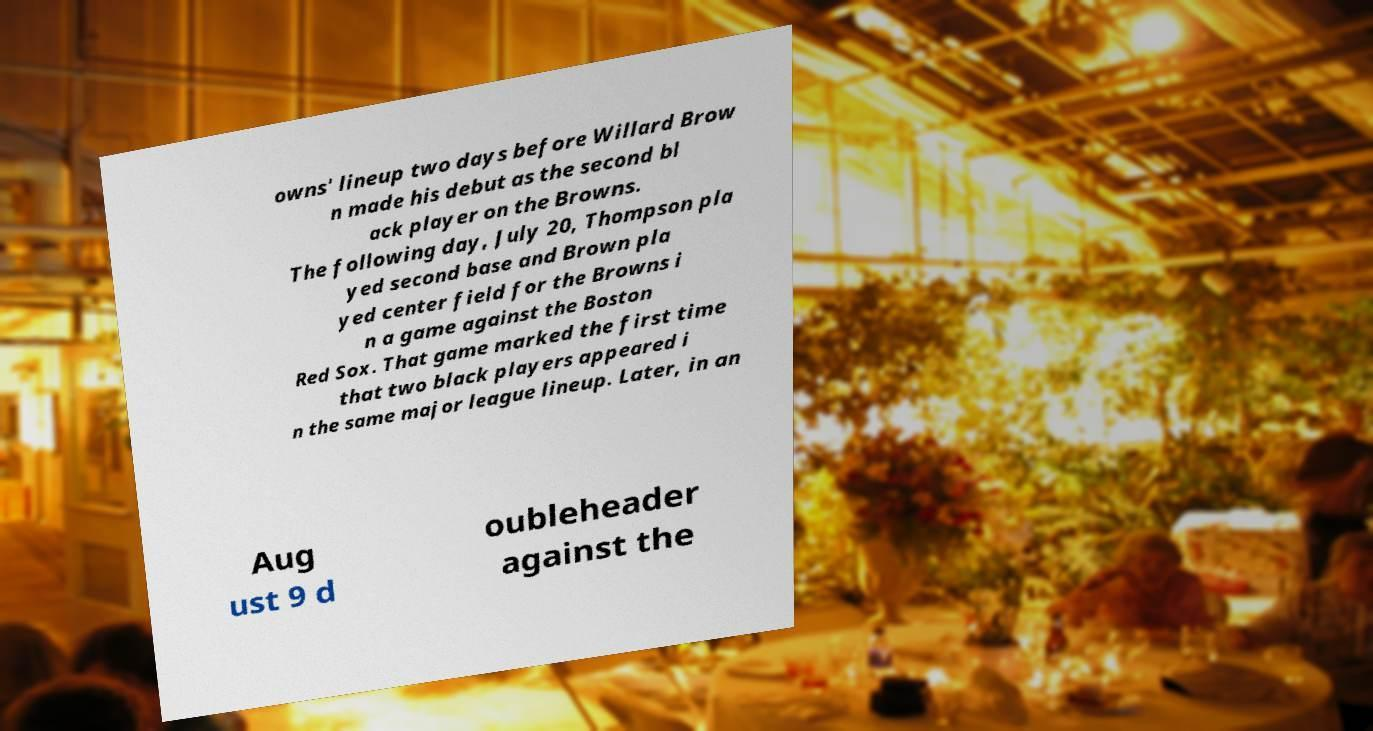Could you extract and type out the text from this image? owns' lineup two days before Willard Brow n made his debut as the second bl ack player on the Browns. The following day, July 20, Thompson pla yed second base and Brown pla yed center field for the Browns i n a game against the Boston Red Sox. That game marked the first time that two black players appeared i n the same major league lineup. Later, in an Aug ust 9 d oubleheader against the 